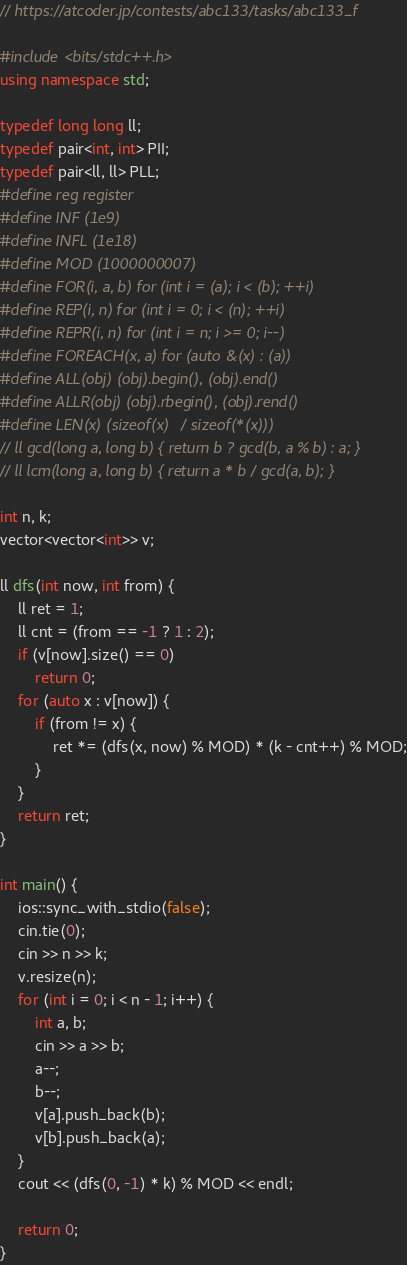<code> <loc_0><loc_0><loc_500><loc_500><_C++_>// https://atcoder.jp/contests/abc133/tasks/abc133_f

#include <bits/stdc++.h>
using namespace std;

typedef long long ll;
typedef pair<int, int> PII;
typedef pair<ll, ll> PLL;
#define reg register
#define INF (1e9)
#define INFL (1e18)
#define MOD (1000000007)
#define FOR(i, a, b) for (int i = (a); i < (b); ++i)
#define REP(i, n) for (int i = 0; i < (n); ++i)
#define REPR(i, n) for (int i = n; i >= 0; i--)
#define FOREACH(x, a) for (auto &(x) : (a))
#define ALL(obj) (obj).begin(), (obj).end()
#define ALLR(obj) (obj).rbegin(), (obj).rend()
#define LEN(x) (sizeof(x) / sizeof(*(x)))
// ll gcd(long a, long b) { return b ? gcd(b, a % b) : a; }
// ll lcm(long a, long b) { return a * b / gcd(a, b); }

int n, k;
vector<vector<int>> v;

ll dfs(int now, int from) {
    ll ret = 1;
    ll cnt = (from == -1 ? 1 : 2);
    if (v[now].size() == 0)
        return 0;
    for (auto x : v[now]) {
        if (from != x) {
            ret *= (dfs(x, now) % MOD) * (k - cnt++) % MOD;
        }
    }
    return ret;
}

int main() {
    ios::sync_with_stdio(false);
    cin.tie(0);
    cin >> n >> k;
    v.resize(n);
    for (int i = 0; i < n - 1; i++) {
        int a, b;
        cin >> a >> b;
        a--;
        b--;
        v[a].push_back(b);
        v[b].push_back(a);
    }
    cout << (dfs(0, -1) * k) % MOD << endl;

    return 0;
}
</code> 